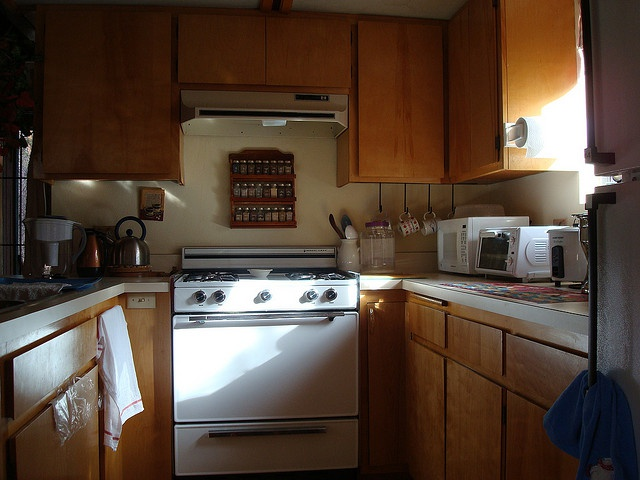Describe the objects in this image and their specific colors. I can see oven in black, white, gray, and darkgray tones, refrigerator in black and gray tones, oven in black, gray, darkgray, and lavender tones, microwave in black, gray, and darkgray tones, and sink in black and gray tones in this image. 